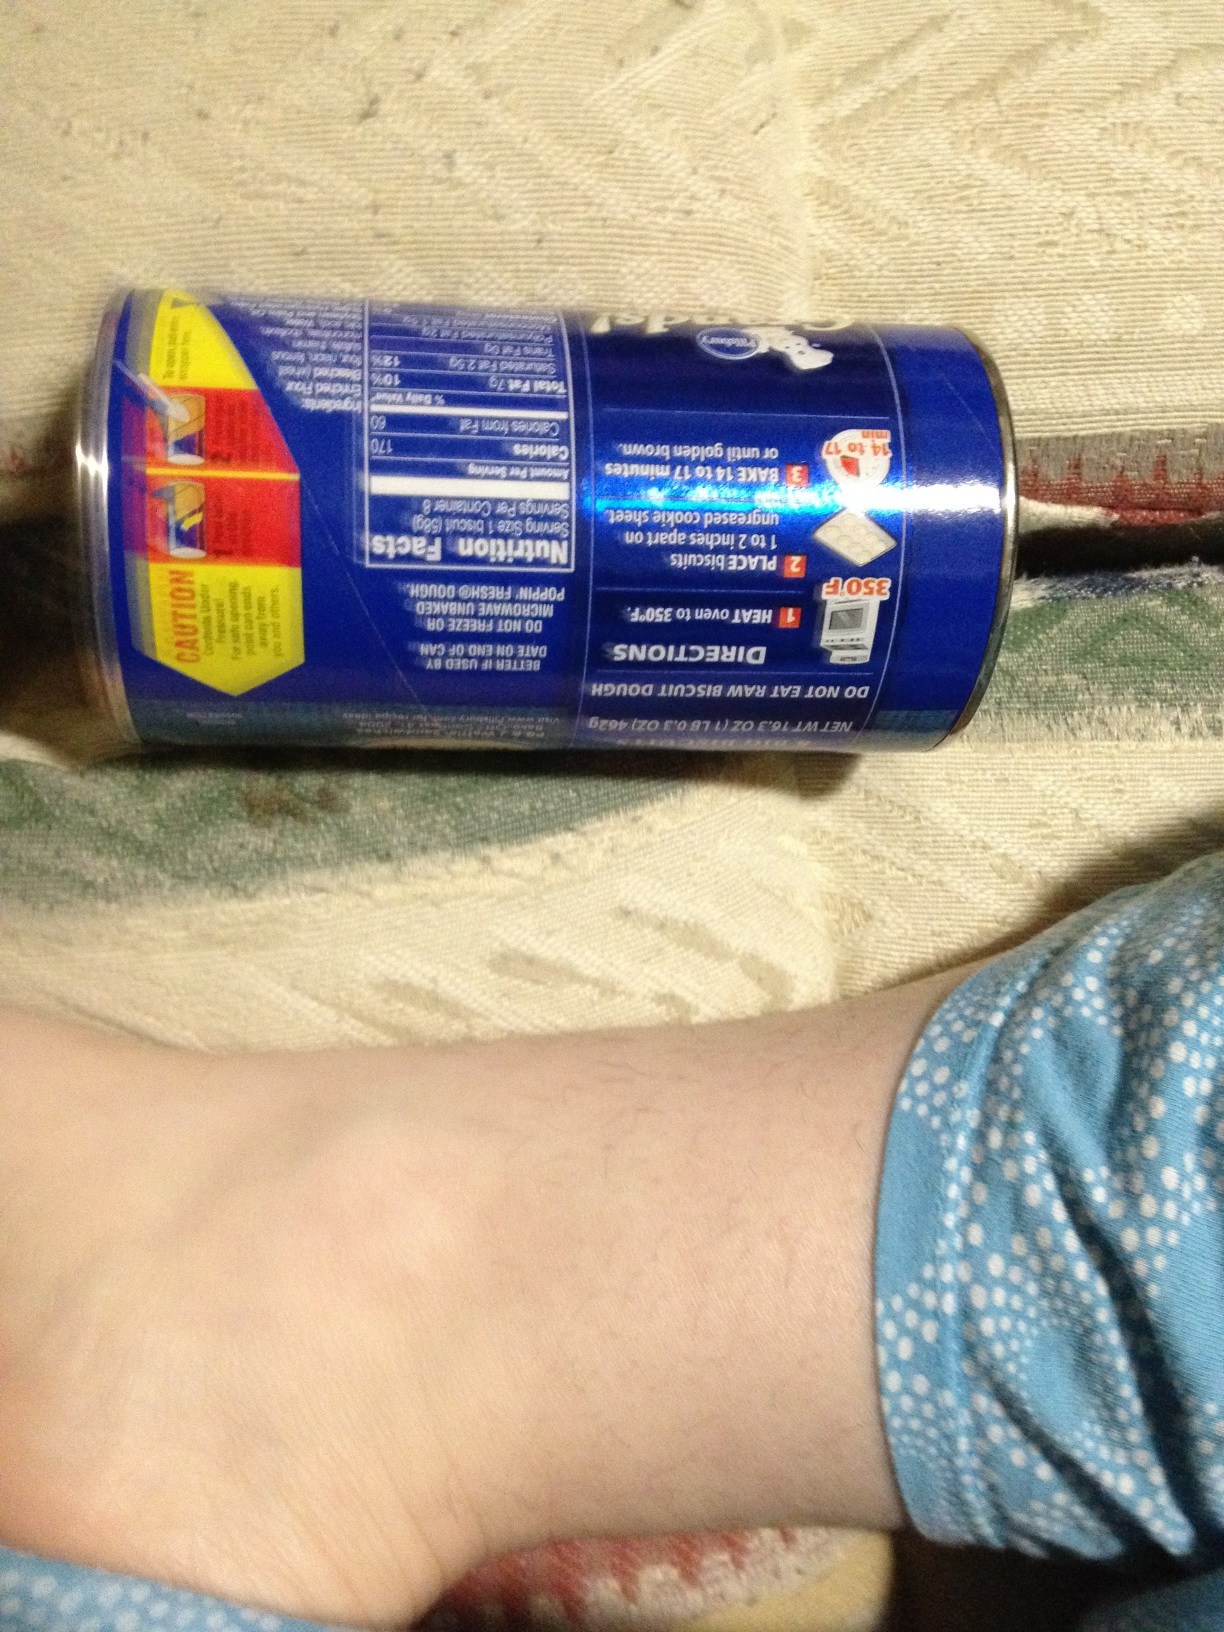If you had to imagine a story about these biscuits, what would it be? Once upon a time, in a cozy kitchen at the edge of a magical forest, these biscuits were baked by a friendly wood elf named Elowen. Her secret ingredient was a sprinkle of enchanted forest dew, gathered during the first light of dawn. Every bite of the biscuit brought a sense of warmth and happiness, filling the eater with a heartwarming memory of a forest adventure. These biscuits became famous in the village, and visitors from afar would trek through the forest to taste a piece of Elowen’s magical creation. 